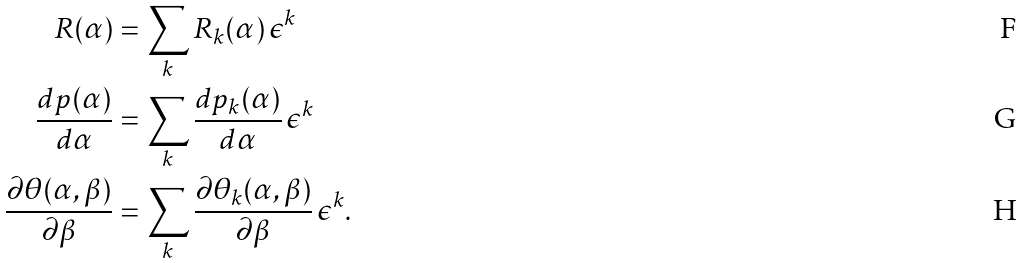<formula> <loc_0><loc_0><loc_500><loc_500>R ( \alpha ) & = \sum _ { k } R _ { k } ( \alpha ) \, \epsilon ^ { k } \\ \frac { d p ( \alpha ) } { d \alpha } & = \sum _ { k } \frac { d p _ { k } ( \alpha ) } { d \alpha } \, \epsilon ^ { k } \\ \frac { \partial \theta ( \alpha , \beta ) } { \partial \beta } & = \sum _ { k } \frac { \partial \theta _ { k } ( \alpha , \beta ) } { \partial \beta } \, \epsilon ^ { k } .</formula> 